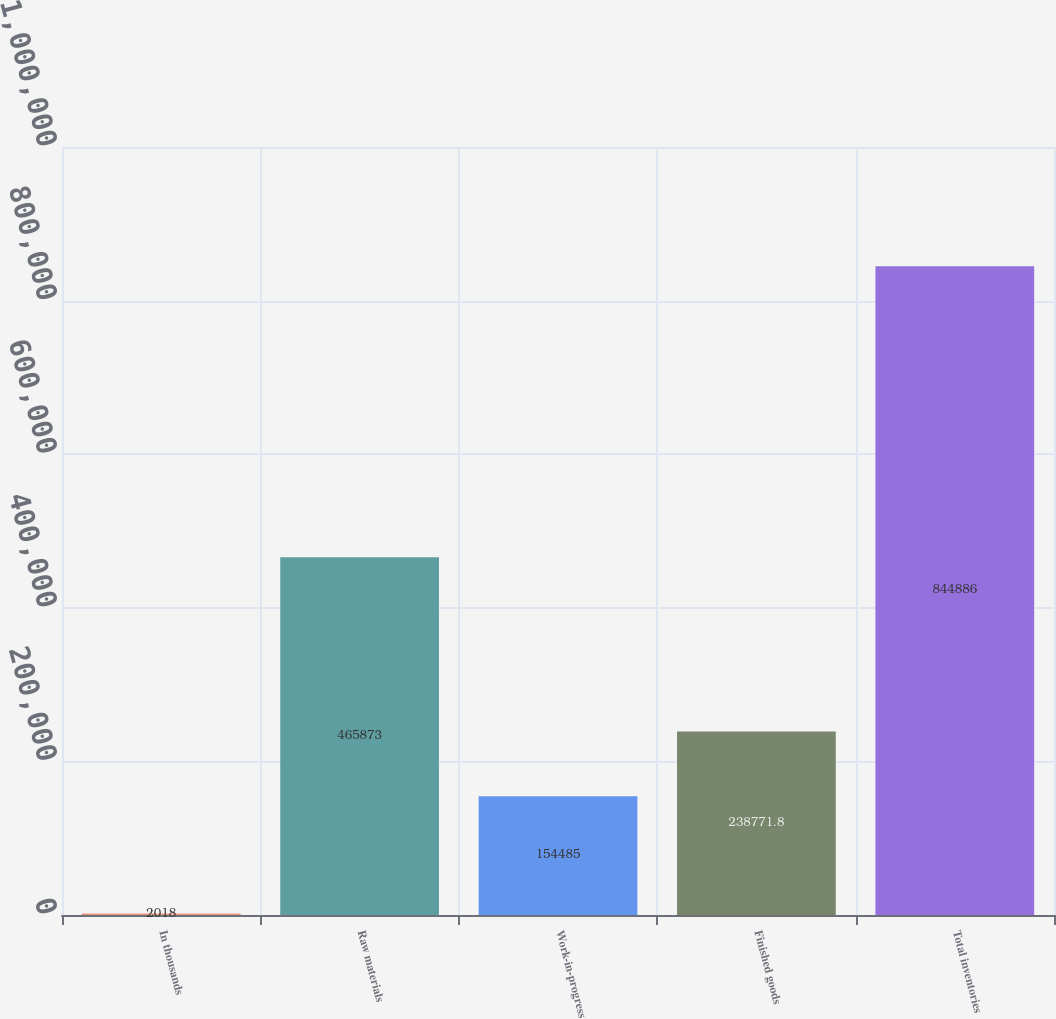Convert chart to OTSL. <chart><loc_0><loc_0><loc_500><loc_500><bar_chart><fcel>In thousands<fcel>Raw materials<fcel>Work-in-progress<fcel>Finished goods<fcel>Total inventories<nl><fcel>2018<fcel>465873<fcel>154485<fcel>238772<fcel>844886<nl></chart> 